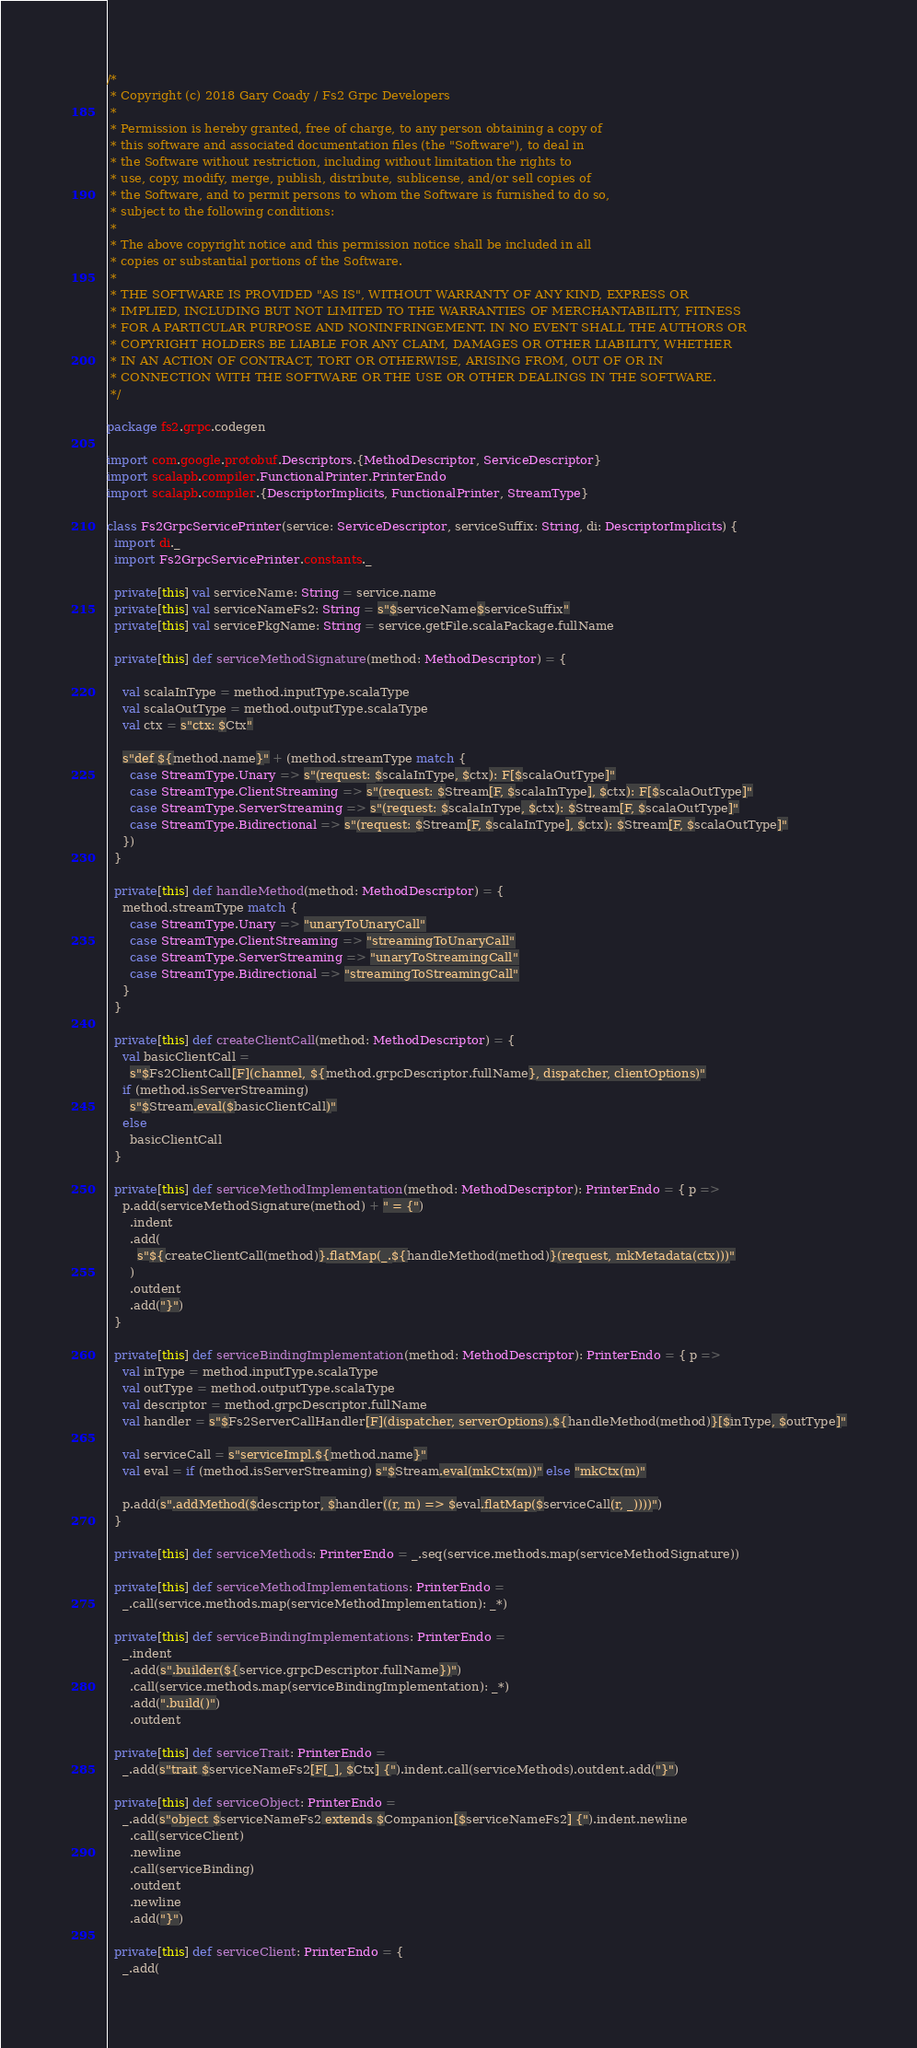<code> <loc_0><loc_0><loc_500><loc_500><_Scala_>/*
 * Copyright (c) 2018 Gary Coady / Fs2 Grpc Developers
 *
 * Permission is hereby granted, free of charge, to any person obtaining a copy of
 * this software and associated documentation files (the "Software"), to deal in
 * the Software without restriction, including without limitation the rights to
 * use, copy, modify, merge, publish, distribute, sublicense, and/or sell copies of
 * the Software, and to permit persons to whom the Software is furnished to do so,
 * subject to the following conditions:
 *
 * The above copyright notice and this permission notice shall be included in all
 * copies or substantial portions of the Software.
 *
 * THE SOFTWARE IS PROVIDED "AS IS", WITHOUT WARRANTY OF ANY KIND, EXPRESS OR
 * IMPLIED, INCLUDING BUT NOT LIMITED TO THE WARRANTIES OF MERCHANTABILITY, FITNESS
 * FOR A PARTICULAR PURPOSE AND NONINFRINGEMENT. IN NO EVENT SHALL THE AUTHORS OR
 * COPYRIGHT HOLDERS BE LIABLE FOR ANY CLAIM, DAMAGES OR OTHER LIABILITY, WHETHER
 * IN AN ACTION OF CONTRACT, TORT OR OTHERWISE, ARISING FROM, OUT OF OR IN
 * CONNECTION WITH THE SOFTWARE OR THE USE OR OTHER DEALINGS IN THE SOFTWARE.
 */

package fs2.grpc.codegen

import com.google.protobuf.Descriptors.{MethodDescriptor, ServiceDescriptor}
import scalapb.compiler.FunctionalPrinter.PrinterEndo
import scalapb.compiler.{DescriptorImplicits, FunctionalPrinter, StreamType}

class Fs2GrpcServicePrinter(service: ServiceDescriptor, serviceSuffix: String, di: DescriptorImplicits) {
  import di._
  import Fs2GrpcServicePrinter.constants._

  private[this] val serviceName: String = service.name
  private[this] val serviceNameFs2: String = s"$serviceName$serviceSuffix"
  private[this] val servicePkgName: String = service.getFile.scalaPackage.fullName

  private[this] def serviceMethodSignature(method: MethodDescriptor) = {

    val scalaInType = method.inputType.scalaType
    val scalaOutType = method.outputType.scalaType
    val ctx = s"ctx: $Ctx"

    s"def ${method.name}" + (method.streamType match {
      case StreamType.Unary => s"(request: $scalaInType, $ctx): F[$scalaOutType]"
      case StreamType.ClientStreaming => s"(request: $Stream[F, $scalaInType], $ctx): F[$scalaOutType]"
      case StreamType.ServerStreaming => s"(request: $scalaInType, $ctx): $Stream[F, $scalaOutType]"
      case StreamType.Bidirectional => s"(request: $Stream[F, $scalaInType], $ctx): $Stream[F, $scalaOutType]"
    })
  }

  private[this] def handleMethod(method: MethodDescriptor) = {
    method.streamType match {
      case StreamType.Unary => "unaryToUnaryCall"
      case StreamType.ClientStreaming => "streamingToUnaryCall"
      case StreamType.ServerStreaming => "unaryToStreamingCall"
      case StreamType.Bidirectional => "streamingToStreamingCall"
    }
  }

  private[this] def createClientCall(method: MethodDescriptor) = {
    val basicClientCall =
      s"$Fs2ClientCall[F](channel, ${method.grpcDescriptor.fullName}, dispatcher, clientOptions)"
    if (method.isServerStreaming)
      s"$Stream.eval($basicClientCall)"
    else
      basicClientCall
  }

  private[this] def serviceMethodImplementation(method: MethodDescriptor): PrinterEndo = { p =>
    p.add(serviceMethodSignature(method) + " = {")
      .indent
      .add(
        s"${createClientCall(method)}.flatMap(_.${handleMethod(method)}(request, mkMetadata(ctx)))"
      )
      .outdent
      .add("}")
  }

  private[this] def serviceBindingImplementation(method: MethodDescriptor): PrinterEndo = { p =>
    val inType = method.inputType.scalaType
    val outType = method.outputType.scalaType
    val descriptor = method.grpcDescriptor.fullName
    val handler = s"$Fs2ServerCallHandler[F](dispatcher, serverOptions).${handleMethod(method)}[$inType, $outType]"

    val serviceCall = s"serviceImpl.${method.name}"
    val eval = if (method.isServerStreaming) s"$Stream.eval(mkCtx(m))" else "mkCtx(m)"

    p.add(s".addMethod($descriptor, $handler((r, m) => $eval.flatMap($serviceCall(r, _))))")
  }

  private[this] def serviceMethods: PrinterEndo = _.seq(service.methods.map(serviceMethodSignature))

  private[this] def serviceMethodImplementations: PrinterEndo =
    _.call(service.methods.map(serviceMethodImplementation): _*)

  private[this] def serviceBindingImplementations: PrinterEndo =
    _.indent
      .add(s".builder(${service.grpcDescriptor.fullName})")
      .call(service.methods.map(serviceBindingImplementation): _*)
      .add(".build()")
      .outdent

  private[this] def serviceTrait: PrinterEndo =
    _.add(s"trait $serviceNameFs2[F[_], $Ctx] {").indent.call(serviceMethods).outdent.add("}")

  private[this] def serviceObject: PrinterEndo =
    _.add(s"object $serviceNameFs2 extends $Companion[$serviceNameFs2] {").indent.newline
      .call(serviceClient)
      .newline
      .call(serviceBinding)
      .outdent
      .newline
      .add("}")

  private[this] def serviceClient: PrinterEndo = {
    _.add(</code> 